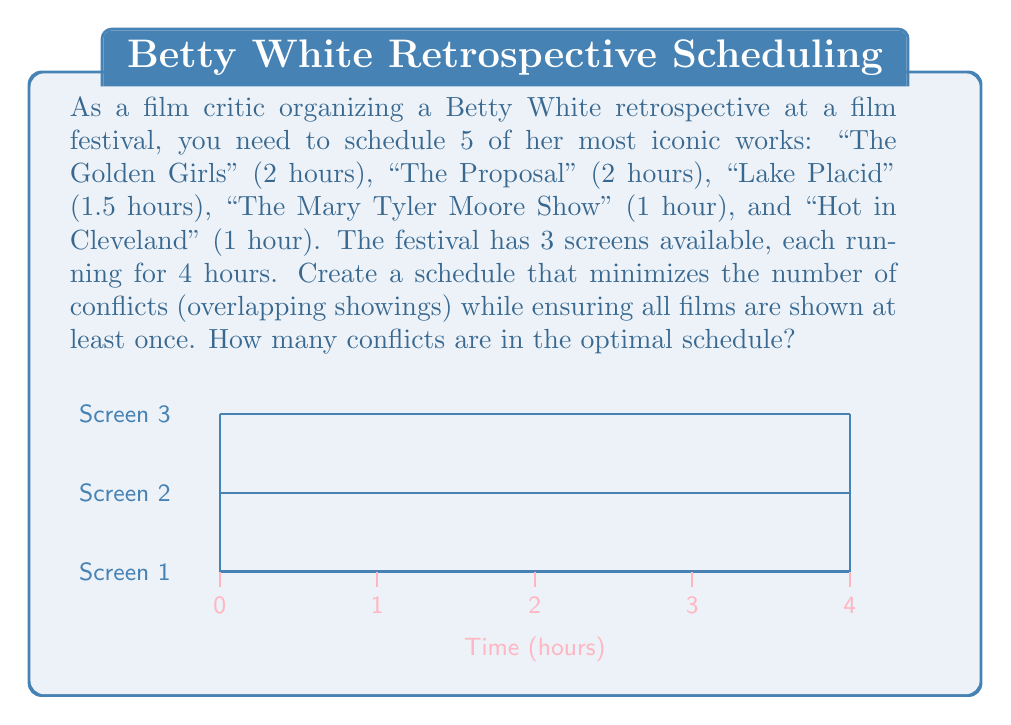Could you help me with this problem? To solve this problem, we'll use a greedy algorithm approach:

1) Sort the movies in descending order of duration:
   - Golden Girls (2h)
   - The Proposal (2h)
   - Lake Placid (1.5h)
   - Mary Tyler Moore Show (1h)
   - Hot in Cleveland (1h)

2) Start scheduling from the longest movie:

   Screen 1: Golden Girls (0-2h)
   Screen 2: The Proposal (0-2h)
   Screen 3: Lake Placid (0-1.5h)

3) Now we have 2.5h left on Screen 3, and 2h each on Screens 1 and 2:

   Screen 1: Golden Girls (0-2h), Mary Tyler Moore Show (2-3h)
   Screen 2: The Proposal (0-2h), Hot in Cleveland (2-3h)
   Screen 3: Lake Placid (0-1.5h)

4) We've scheduled all movies at least once, using all available time slots without any conflicts.

The number of conflicts in this optimal schedule is 0.

To prove this is optimal:
- Total movie duration = 2 + 2 + 1.5 + 1 + 1 = 7.5 hours
- Total available screen time = 3 screens * 4 hours = 12 hours

Since 7.5 < 12, it's theoretically possible to schedule all movies without conflicts, which our solution achieves.

The mathematical representation of this schedule can be expressed as:

$$
\begin{align*}
x_{11} &= 1, \quad x_{14} = 1 \\
x_{22} &= 1, \quad x_{25} = 1 \\
x_{33} &= 1
\end{align*}
$$

Where $x_{ij}$ = 1 if movie $i$ is scheduled on screen $j$, and 0 otherwise.
Answer: 0 conflicts 